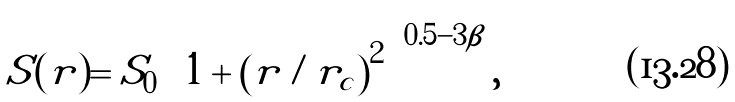Convert formula to latex. <formula><loc_0><loc_0><loc_500><loc_500>S ( r ) = S _ { 0 } \left [ 1 + \left ( r / r _ { c } \right ) ^ { 2 } \right ] ^ { 0 . 5 - 3 \beta } ,</formula> 